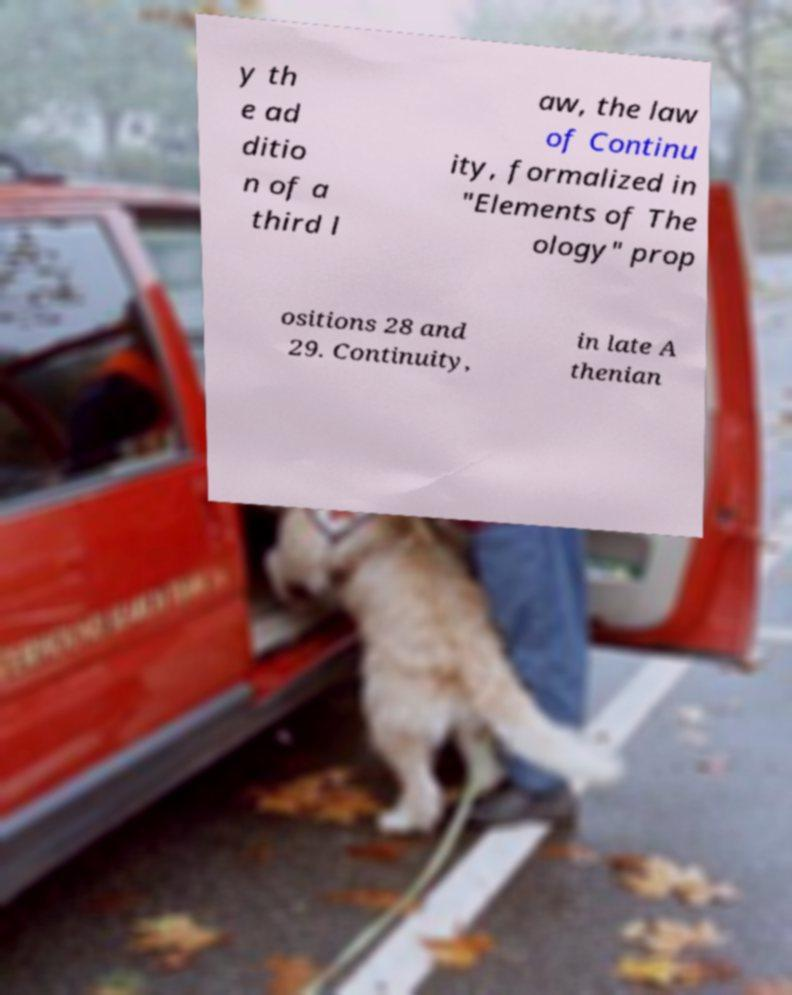I need the written content from this picture converted into text. Can you do that? y th e ad ditio n of a third l aw, the law of Continu ity, formalized in "Elements of The ology" prop ositions 28 and 29. Continuity, in late A thenian 